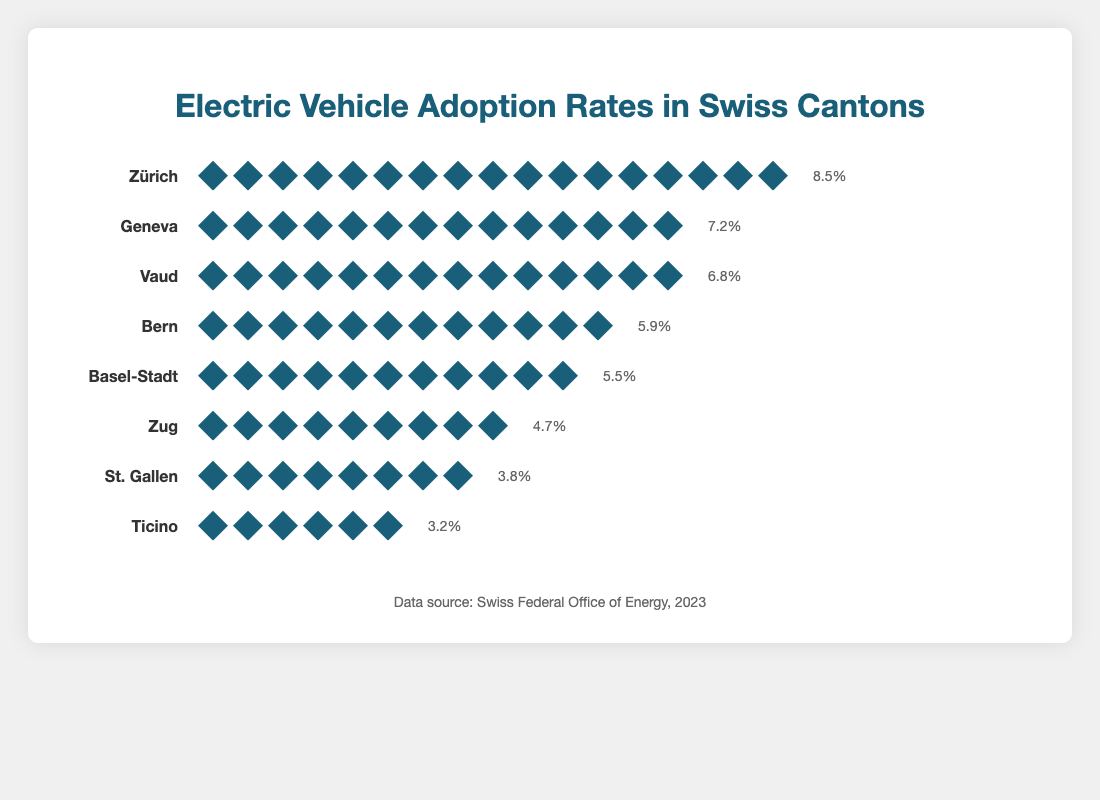Which canton has the highest EV adoption rate? The title "Electric Vehicle Adoption Rates in Swiss Cantons" indicates various cantons and their respective adoption rates. By glancing at the plotted data, Zürich leads with the EV adoption rate of 8.5%.
Answer: Zürich How many cantons have an EV adoption rate above 6%? By examining each canton’s data and counting those with an adoption rate greater than 6%, Zürich (8.5%), Geneva (7.2%), and Vaud (6.8%) meet this criterion, resulting in three cantons.
Answer: 3 Which canton has the lowest number of EV icons? The visual representation uses EV icons to denote adoption rates. Ticino has the fewest with 6 EV icons corresponding to a 3.2% adoption rate.
Answer: Ticino What is the total number of EV icons for all cantons combined? Summing the icon counts for all listed cantons: 17 (Zürich) + 14 (Geneva) + 14 (Vaud) + 12 (Bern) + 11 (Basel-Stadt) + 9 (Zug) + 8 (St. Gallen) + 6 (Ticino) = 91.
Answer: 91 Which canton has more EV icons, Bern or Zug? Comparing the icon counts for Bern and Zug, Bern has 12 icons whereas Zug has 9 icons. Thus, Bern has more EV icons.
Answer: Bern What is the average EV adoption rate among all the cantons shown? Calculating the average involves summing the adoption rates and dividing by the number of cantons: (8.5 + 7.2 + 6.8 + 5.9 + 5.5 + 4.7 + 3.8 + 3.2) / 8 = 45.6 / 8 = 5.7.
Answer: 5.7 Is the adoption rate of Geneva closer to Zürich or Vaud? Converting differences: Geneva to Zürich (8.5 - 7.2) = 1.3%, Geneva to Vaud (7.2 - 6.8) = 0.4%. Since 0.4% < 1.3%, Geneva’s rate is closer to Vaud.
Answer: Vaud How many more EV icons does Zürich have compared to Ticino? Subtracting Ticino's icon count from Zürich’s: 17 (Zürich) - 6 (Ticino) = 11. Thus, Zürich has 11 more EV icons than Ticino.
Answer: 11 Which cantons have identical numbers of EV icons? By comparing the counts, both Geneva and Vaud have 14 icons each.
Answer: Geneva and Vaud What is the difference in EV adoption rates between St. Gallen and Basel-Stadt? Subtracting St. Gallen’s rate from Basel-Stadt’s: 5.5% (Basel-Stadt) - 3.8% (St. Gallen) = 1.7%. So, the difference is 1.7%.
Answer: 1.7% 